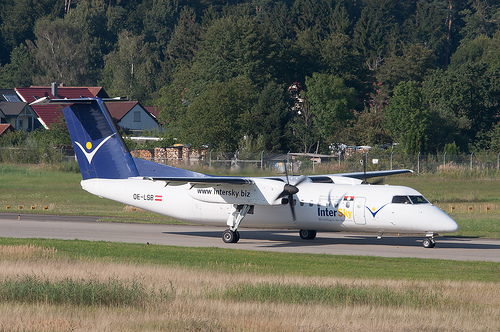Describe the setting where this airplane is situated. The airplane is situated at an airport surrounded by a lush, green landscape. The background includes a mix of trees, bushes, and nearby structures, creating a picturesque and serene environment. The runway is well-maintained, and the presence of grass along the edges adds a natural touch to the artificially constructed area. 